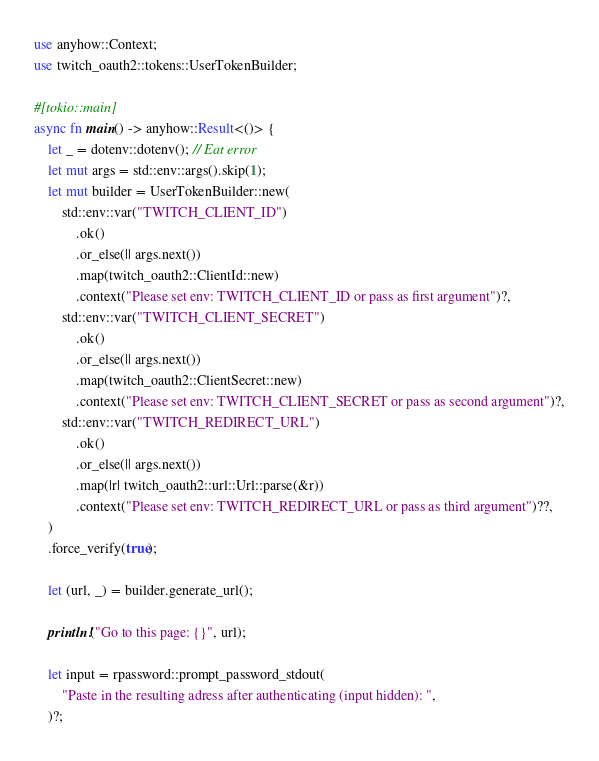Convert code to text. <code><loc_0><loc_0><loc_500><loc_500><_Rust_>use anyhow::Context;
use twitch_oauth2::tokens::UserTokenBuilder;

#[tokio::main]
async fn main() -> anyhow::Result<()> {
    let _ = dotenv::dotenv(); // Eat error
    let mut args = std::env::args().skip(1);
    let mut builder = UserTokenBuilder::new(
        std::env::var("TWITCH_CLIENT_ID")
            .ok()
            .or_else(|| args.next())
            .map(twitch_oauth2::ClientId::new)
            .context("Please set env: TWITCH_CLIENT_ID or pass as first argument")?,
        std::env::var("TWITCH_CLIENT_SECRET")
            .ok()
            .or_else(|| args.next())
            .map(twitch_oauth2::ClientSecret::new)
            .context("Please set env: TWITCH_CLIENT_SECRET or pass as second argument")?,
        std::env::var("TWITCH_REDIRECT_URL")
            .ok()
            .or_else(|| args.next())
            .map(|r| twitch_oauth2::url::Url::parse(&r))
            .context("Please set env: TWITCH_REDIRECT_URL or pass as third argument")??,
    )
    .force_verify(true);

    let (url, _) = builder.generate_url();

    println!("Go to this page: {}", url);

    let input = rpassword::prompt_password_stdout(
        "Paste in the resulting adress after authenticating (input hidden): ",
    )?;
</code> 